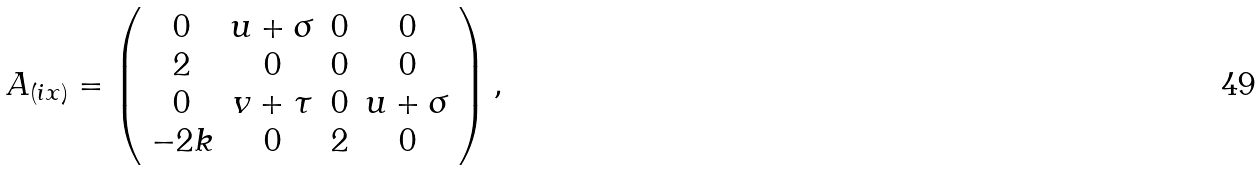<formula> <loc_0><loc_0><loc_500><loc_500>A _ { ( i x ) } = \left ( \begin{array} { c c c c } 0 & u + \sigma & 0 & 0 \\ 2 & 0 & 0 & 0 \\ 0 & v + \tau & 0 & u + \sigma \\ - 2 k & 0 & 2 & 0 \end{array} \right ) ,</formula> 